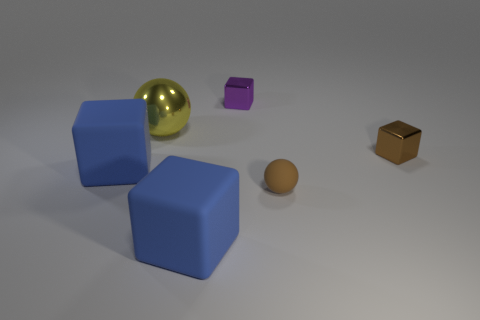Add 4 small gray metallic blocks. How many objects exist? 10 Subtract all blocks. How many objects are left? 2 Subtract all yellow objects. Subtract all small brown matte spheres. How many objects are left? 4 Add 4 tiny brown objects. How many tiny brown objects are left? 6 Add 4 big rubber objects. How many big rubber objects exist? 6 Subtract 0 green spheres. How many objects are left? 6 